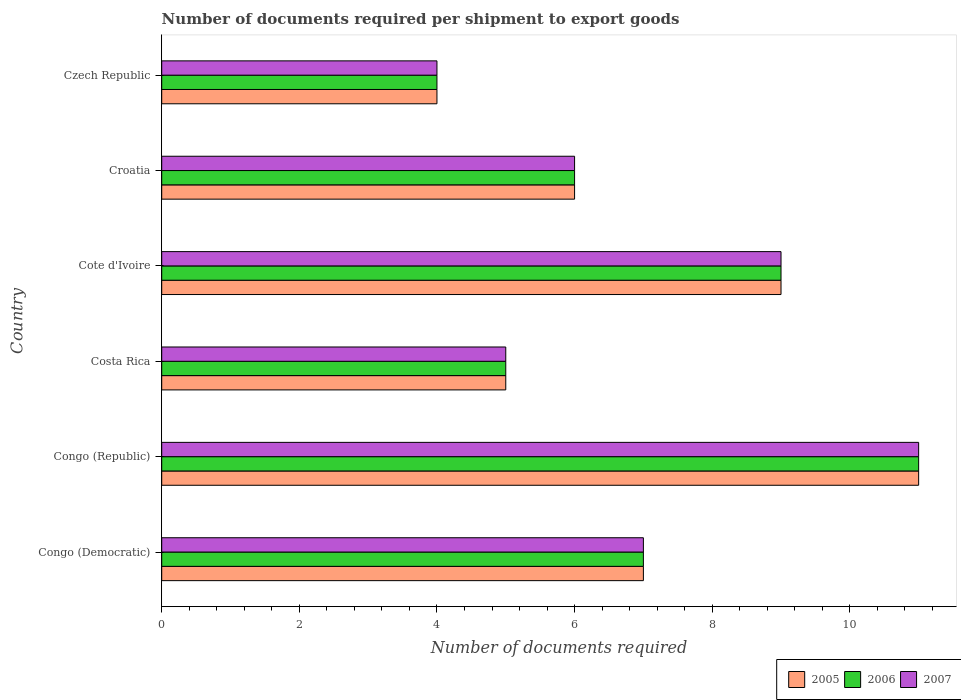Are the number of bars per tick equal to the number of legend labels?
Provide a succinct answer. Yes. Are the number of bars on each tick of the Y-axis equal?
Your response must be concise. Yes. How many bars are there on the 3rd tick from the bottom?
Your answer should be very brief. 3. What is the label of the 5th group of bars from the top?
Provide a short and direct response. Congo (Republic). Across all countries, what is the minimum number of documents required per shipment to export goods in 2005?
Your answer should be very brief. 4. In which country was the number of documents required per shipment to export goods in 2005 maximum?
Your response must be concise. Congo (Republic). In which country was the number of documents required per shipment to export goods in 2006 minimum?
Make the answer very short. Czech Republic. What is the total number of documents required per shipment to export goods in 2006 in the graph?
Your answer should be compact. 42. What is the average number of documents required per shipment to export goods in 2006 per country?
Provide a short and direct response. 7. In how many countries, is the number of documents required per shipment to export goods in 2007 greater than 3.2 ?
Provide a succinct answer. 6. What is the ratio of the number of documents required per shipment to export goods in 2006 in Costa Rica to that in Czech Republic?
Provide a short and direct response. 1.25. Is the number of documents required per shipment to export goods in 2005 in Congo (Republic) less than that in Croatia?
Offer a terse response. No. What is the difference between the highest and the second highest number of documents required per shipment to export goods in 2006?
Provide a succinct answer. 2. What is the difference between the highest and the lowest number of documents required per shipment to export goods in 2006?
Ensure brevity in your answer.  7. What does the 2nd bar from the bottom in Congo (Democratic) represents?
Provide a short and direct response. 2006. Is it the case that in every country, the sum of the number of documents required per shipment to export goods in 2007 and number of documents required per shipment to export goods in 2005 is greater than the number of documents required per shipment to export goods in 2006?
Your answer should be very brief. Yes. How many bars are there?
Provide a short and direct response. 18. Are all the bars in the graph horizontal?
Your response must be concise. Yes. How many countries are there in the graph?
Provide a short and direct response. 6. What is the difference between two consecutive major ticks on the X-axis?
Make the answer very short. 2. Does the graph contain any zero values?
Provide a succinct answer. No. Where does the legend appear in the graph?
Give a very brief answer. Bottom right. How many legend labels are there?
Your answer should be very brief. 3. What is the title of the graph?
Provide a succinct answer. Number of documents required per shipment to export goods. What is the label or title of the X-axis?
Your answer should be compact. Number of documents required. What is the label or title of the Y-axis?
Provide a succinct answer. Country. What is the Number of documents required in 2006 in Congo (Democratic)?
Your answer should be very brief. 7. What is the Number of documents required in 2005 in Congo (Republic)?
Keep it short and to the point. 11. What is the Number of documents required of 2007 in Congo (Republic)?
Your answer should be very brief. 11. What is the Number of documents required of 2005 in Costa Rica?
Your response must be concise. 5. What is the Number of documents required of 2006 in Costa Rica?
Your answer should be compact. 5. What is the Number of documents required in 2005 in Cote d'Ivoire?
Keep it short and to the point. 9. What is the Number of documents required of 2006 in Cote d'Ivoire?
Make the answer very short. 9. What is the Number of documents required of 2007 in Cote d'Ivoire?
Offer a terse response. 9. What is the Number of documents required of 2006 in Croatia?
Keep it short and to the point. 6. What is the Number of documents required of 2006 in Czech Republic?
Provide a succinct answer. 4. Across all countries, what is the maximum Number of documents required in 2006?
Offer a terse response. 11. Across all countries, what is the minimum Number of documents required in 2005?
Offer a terse response. 4. What is the total Number of documents required of 2006 in the graph?
Provide a short and direct response. 42. What is the difference between the Number of documents required in 2005 in Congo (Democratic) and that in Congo (Republic)?
Make the answer very short. -4. What is the difference between the Number of documents required of 2006 in Congo (Democratic) and that in Congo (Republic)?
Offer a very short reply. -4. What is the difference between the Number of documents required of 2007 in Congo (Democratic) and that in Congo (Republic)?
Your answer should be compact. -4. What is the difference between the Number of documents required in 2005 in Congo (Democratic) and that in Costa Rica?
Your answer should be very brief. 2. What is the difference between the Number of documents required in 2006 in Congo (Democratic) and that in Costa Rica?
Keep it short and to the point. 2. What is the difference between the Number of documents required of 2006 in Congo (Democratic) and that in Cote d'Ivoire?
Offer a terse response. -2. What is the difference between the Number of documents required of 2007 in Congo (Democratic) and that in Cote d'Ivoire?
Provide a short and direct response. -2. What is the difference between the Number of documents required of 2006 in Congo (Democratic) and that in Croatia?
Provide a succinct answer. 1. What is the difference between the Number of documents required of 2007 in Congo (Democratic) and that in Croatia?
Your answer should be very brief. 1. What is the difference between the Number of documents required in 2005 in Congo (Democratic) and that in Czech Republic?
Provide a succinct answer. 3. What is the difference between the Number of documents required in 2006 in Congo (Democratic) and that in Czech Republic?
Ensure brevity in your answer.  3. What is the difference between the Number of documents required of 2006 in Congo (Republic) and that in Costa Rica?
Make the answer very short. 6. What is the difference between the Number of documents required in 2005 in Congo (Republic) and that in Cote d'Ivoire?
Provide a short and direct response. 2. What is the difference between the Number of documents required in 2006 in Congo (Republic) and that in Cote d'Ivoire?
Your answer should be compact. 2. What is the difference between the Number of documents required in 2005 in Congo (Republic) and that in Croatia?
Your answer should be very brief. 5. What is the difference between the Number of documents required of 2006 in Costa Rica and that in Cote d'Ivoire?
Give a very brief answer. -4. What is the difference between the Number of documents required in 2007 in Costa Rica and that in Cote d'Ivoire?
Keep it short and to the point. -4. What is the difference between the Number of documents required of 2005 in Costa Rica and that in Croatia?
Offer a terse response. -1. What is the difference between the Number of documents required in 2005 in Costa Rica and that in Czech Republic?
Provide a succinct answer. 1. What is the difference between the Number of documents required of 2006 in Costa Rica and that in Czech Republic?
Offer a very short reply. 1. What is the difference between the Number of documents required of 2006 in Cote d'Ivoire and that in Czech Republic?
Your answer should be very brief. 5. What is the difference between the Number of documents required of 2007 in Cote d'Ivoire and that in Czech Republic?
Offer a terse response. 5. What is the difference between the Number of documents required of 2005 in Croatia and that in Czech Republic?
Offer a terse response. 2. What is the difference between the Number of documents required in 2006 in Croatia and that in Czech Republic?
Give a very brief answer. 2. What is the difference between the Number of documents required of 2007 in Croatia and that in Czech Republic?
Give a very brief answer. 2. What is the difference between the Number of documents required of 2005 in Congo (Democratic) and the Number of documents required of 2007 in Congo (Republic)?
Your answer should be very brief. -4. What is the difference between the Number of documents required of 2005 in Congo (Democratic) and the Number of documents required of 2006 in Costa Rica?
Provide a succinct answer. 2. What is the difference between the Number of documents required in 2006 in Congo (Democratic) and the Number of documents required in 2007 in Costa Rica?
Provide a short and direct response. 2. What is the difference between the Number of documents required of 2005 in Congo (Democratic) and the Number of documents required of 2006 in Cote d'Ivoire?
Your answer should be compact. -2. What is the difference between the Number of documents required in 2005 in Congo (Democratic) and the Number of documents required in 2007 in Cote d'Ivoire?
Offer a very short reply. -2. What is the difference between the Number of documents required in 2005 in Congo (Democratic) and the Number of documents required in 2006 in Croatia?
Make the answer very short. 1. What is the difference between the Number of documents required of 2005 in Congo (Democratic) and the Number of documents required of 2007 in Croatia?
Offer a terse response. 1. What is the difference between the Number of documents required of 2006 in Congo (Democratic) and the Number of documents required of 2007 in Czech Republic?
Offer a terse response. 3. What is the difference between the Number of documents required of 2005 in Congo (Republic) and the Number of documents required of 2007 in Costa Rica?
Offer a very short reply. 6. What is the difference between the Number of documents required of 2005 in Congo (Republic) and the Number of documents required of 2007 in Cote d'Ivoire?
Provide a succinct answer. 2. What is the difference between the Number of documents required of 2006 in Congo (Republic) and the Number of documents required of 2007 in Cote d'Ivoire?
Keep it short and to the point. 2. What is the difference between the Number of documents required of 2005 in Congo (Republic) and the Number of documents required of 2006 in Croatia?
Provide a succinct answer. 5. What is the difference between the Number of documents required in 2005 in Congo (Republic) and the Number of documents required in 2007 in Czech Republic?
Your answer should be very brief. 7. What is the difference between the Number of documents required of 2005 in Costa Rica and the Number of documents required of 2006 in Cote d'Ivoire?
Give a very brief answer. -4. What is the difference between the Number of documents required of 2005 in Costa Rica and the Number of documents required of 2007 in Cote d'Ivoire?
Provide a succinct answer. -4. What is the difference between the Number of documents required in 2006 in Cote d'Ivoire and the Number of documents required in 2007 in Croatia?
Give a very brief answer. 3. What is the difference between the Number of documents required of 2005 in Cote d'Ivoire and the Number of documents required of 2006 in Czech Republic?
Offer a very short reply. 5. What is the difference between the Number of documents required in 2005 in Croatia and the Number of documents required in 2006 in Czech Republic?
Make the answer very short. 2. What is the difference between the Number of documents required of 2005 in Croatia and the Number of documents required of 2007 in Czech Republic?
Give a very brief answer. 2. What is the difference between the Number of documents required of 2006 in Croatia and the Number of documents required of 2007 in Czech Republic?
Your response must be concise. 2. What is the average Number of documents required in 2005 per country?
Offer a very short reply. 7. What is the average Number of documents required in 2007 per country?
Make the answer very short. 7. What is the difference between the Number of documents required of 2006 and Number of documents required of 2007 in Congo (Democratic)?
Make the answer very short. 0. What is the difference between the Number of documents required of 2005 and Number of documents required of 2006 in Congo (Republic)?
Offer a terse response. 0. What is the difference between the Number of documents required in 2006 and Number of documents required in 2007 in Congo (Republic)?
Give a very brief answer. 0. What is the difference between the Number of documents required in 2005 and Number of documents required in 2007 in Costa Rica?
Provide a succinct answer. 0. What is the difference between the Number of documents required of 2006 and Number of documents required of 2007 in Cote d'Ivoire?
Offer a terse response. 0. What is the difference between the Number of documents required of 2005 and Number of documents required of 2007 in Croatia?
Ensure brevity in your answer.  0. What is the difference between the Number of documents required in 2006 and Number of documents required in 2007 in Croatia?
Ensure brevity in your answer.  0. What is the difference between the Number of documents required in 2005 and Number of documents required in 2007 in Czech Republic?
Give a very brief answer. 0. What is the difference between the Number of documents required of 2006 and Number of documents required of 2007 in Czech Republic?
Your response must be concise. 0. What is the ratio of the Number of documents required of 2005 in Congo (Democratic) to that in Congo (Republic)?
Your answer should be very brief. 0.64. What is the ratio of the Number of documents required in 2006 in Congo (Democratic) to that in Congo (Republic)?
Your answer should be compact. 0.64. What is the ratio of the Number of documents required in 2007 in Congo (Democratic) to that in Congo (Republic)?
Provide a succinct answer. 0.64. What is the ratio of the Number of documents required in 2005 in Congo (Democratic) to that in Costa Rica?
Your response must be concise. 1.4. What is the ratio of the Number of documents required of 2007 in Congo (Democratic) to that in Costa Rica?
Your response must be concise. 1.4. What is the ratio of the Number of documents required of 2005 in Congo (Democratic) to that in Cote d'Ivoire?
Keep it short and to the point. 0.78. What is the ratio of the Number of documents required of 2006 in Congo (Democratic) to that in Cote d'Ivoire?
Give a very brief answer. 0.78. What is the ratio of the Number of documents required in 2006 in Congo (Democratic) to that in Croatia?
Provide a short and direct response. 1.17. What is the ratio of the Number of documents required of 2005 in Congo (Democratic) to that in Czech Republic?
Provide a short and direct response. 1.75. What is the ratio of the Number of documents required in 2006 in Congo (Democratic) to that in Czech Republic?
Offer a very short reply. 1.75. What is the ratio of the Number of documents required of 2007 in Congo (Democratic) to that in Czech Republic?
Your response must be concise. 1.75. What is the ratio of the Number of documents required in 2005 in Congo (Republic) to that in Costa Rica?
Offer a terse response. 2.2. What is the ratio of the Number of documents required in 2007 in Congo (Republic) to that in Costa Rica?
Your answer should be compact. 2.2. What is the ratio of the Number of documents required in 2005 in Congo (Republic) to that in Cote d'Ivoire?
Offer a very short reply. 1.22. What is the ratio of the Number of documents required of 2006 in Congo (Republic) to that in Cote d'Ivoire?
Ensure brevity in your answer.  1.22. What is the ratio of the Number of documents required of 2007 in Congo (Republic) to that in Cote d'Ivoire?
Offer a terse response. 1.22. What is the ratio of the Number of documents required of 2005 in Congo (Republic) to that in Croatia?
Provide a succinct answer. 1.83. What is the ratio of the Number of documents required of 2006 in Congo (Republic) to that in Croatia?
Your response must be concise. 1.83. What is the ratio of the Number of documents required in 2007 in Congo (Republic) to that in Croatia?
Your response must be concise. 1.83. What is the ratio of the Number of documents required in 2005 in Congo (Republic) to that in Czech Republic?
Offer a terse response. 2.75. What is the ratio of the Number of documents required in 2006 in Congo (Republic) to that in Czech Republic?
Ensure brevity in your answer.  2.75. What is the ratio of the Number of documents required in 2007 in Congo (Republic) to that in Czech Republic?
Your answer should be compact. 2.75. What is the ratio of the Number of documents required in 2005 in Costa Rica to that in Cote d'Ivoire?
Provide a short and direct response. 0.56. What is the ratio of the Number of documents required in 2006 in Costa Rica to that in Cote d'Ivoire?
Your response must be concise. 0.56. What is the ratio of the Number of documents required of 2007 in Costa Rica to that in Cote d'Ivoire?
Your answer should be compact. 0.56. What is the ratio of the Number of documents required in 2005 in Costa Rica to that in Croatia?
Your answer should be very brief. 0.83. What is the ratio of the Number of documents required of 2006 in Costa Rica to that in Croatia?
Keep it short and to the point. 0.83. What is the ratio of the Number of documents required in 2007 in Costa Rica to that in Czech Republic?
Keep it short and to the point. 1.25. What is the ratio of the Number of documents required in 2005 in Cote d'Ivoire to that in Czech Republic?
Make the answer very short. 2.25. What is the ratio of the Number of documents required in 2006 in Cote d'Ivoire to that in Czech Republic?
Your answer should be compact. 2.25. What is the ratio of the Number of documents required in 2007 in Cote d'Ivoire to that in Czech Republic?
Keep it short and to the point. 2.25. What is the ratio of the Number of documents required of 2006 in Croatia to that in Czech Republic?
Offer a very short reply. 1.5. What is the difference between the highest and the second highest Number of documents required of 2006?
Provide a short and direct response. 2. What is the difference between the highest and the second highest Number of documents required in 2007?
Make the answer very short. 2. What is the difference between the highest and the lowest Number of documents required of 2007?
Provide a succinct answer. 7. 